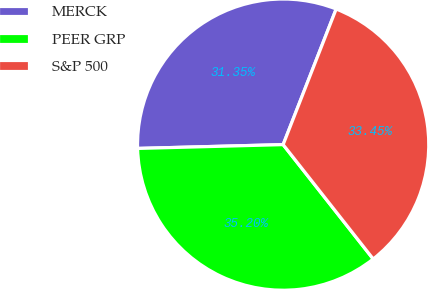Convert chart to OTSL. <chart><loc_0><loc_0><loc_500><loc_500><pie_chart><fcel>MERCK<fcel>PEER GRP<fcel>S&P 500<nl><fcel>31.35%<fcel>35.2%<fcel>33.45%<nl></chart> 